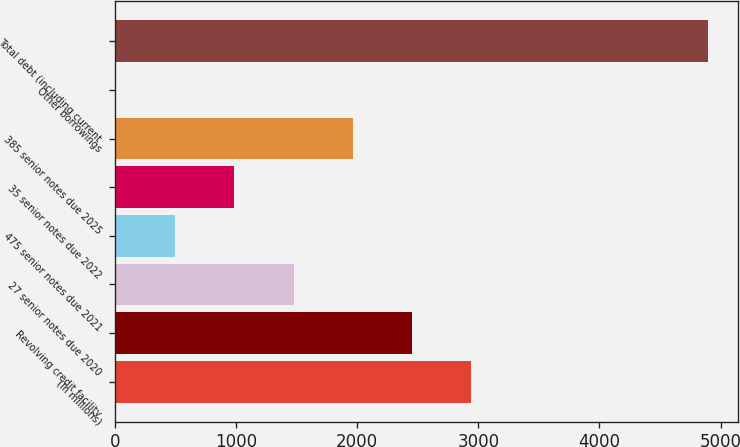Convert chart. <chart><loc_0><loc_0><loc_500><loc_500><bar_chart><fcel>(In millions)<fcel>Revolving credit facility<fcel>27 senior notes due 2020<fcel>475 senior notes due 2021<fcel>35 senior notes due 2022<fcel>385 senior notes due 2025<fcel>Other borrowings<fcel>Total debt (including current<nl><fcel>2943.6<fcel>2454.5<fcel>1476.3<fcel>498.1<fcel>987.2<fcel>1965.4<fcel>9<fcel>4900<nl></chart> 